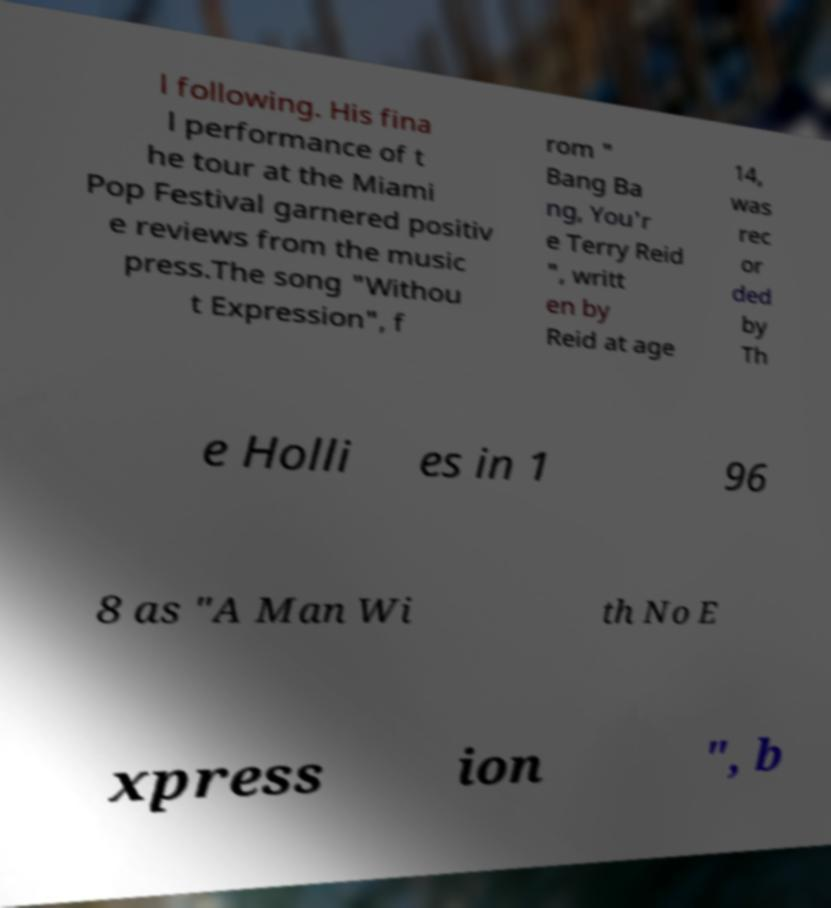Can you read and provide the text displayed in the image?This photo seems to have some interesting text. Can you extract and type it out for me? l following. His fina l performance of t he tour at the Miami Pop Festival garnered positiv e reviews from the music press.The song "Withou t Expression", f rom " Bang Ba ng, You'r e Terry Reid ", writt en by Reid at age 14, was rec or ded by Th e Holli es in 1 96 8 as "A Man Wi th No E xpress ion ", b 